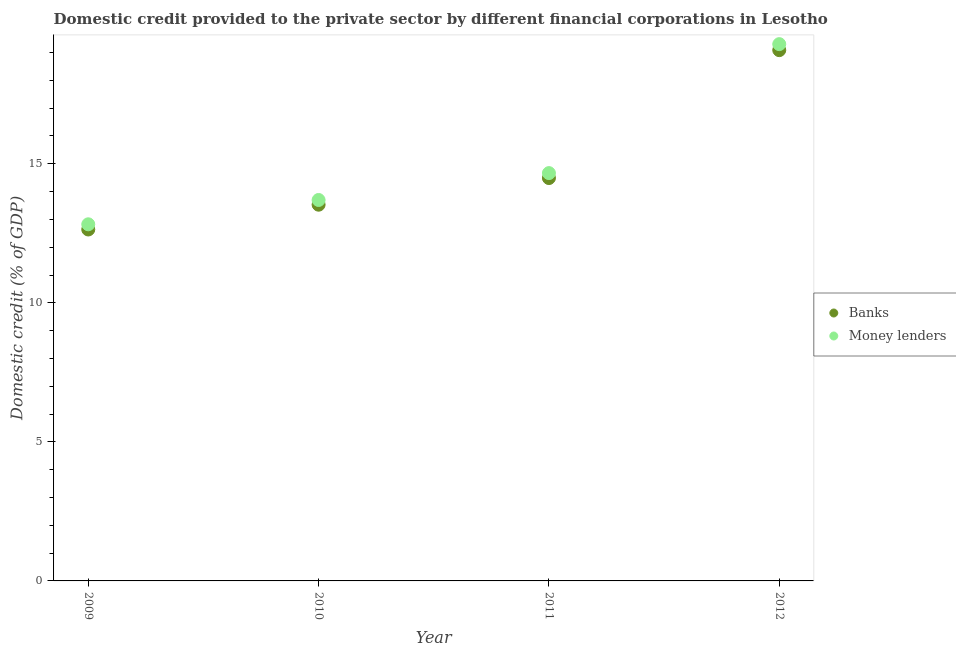How many different coloured dotlines are there?
Offer a terse response. 2. What is the domestic credit provided by banks in 2011?
Provide a short and direct response. 14.49. Across all years, what is the maximum domestic credit provided by money lenders?
Ensure brevity in your answer.  19.3. Across all years, what is the minimum domestic credit provided by money lenders?
Give a very brief answer. 12.82. In which year was the domestic credit provided by banks maximum?
Your response must be concise. 2012. What is the total domestic credit provided by money lenders in the graph?
Ensure brevity in your answer.  60.49. What is the difference between the domestic credit provided by money lenders in 2009 and that in 2011?
Provide a short and direct response. -1.84. What is the difference between the domestic credit provided by money lenders in 2010 and the domestic credit provided by banks in 2009?
Provide a succinct answer. 1.06. What is the average domestic credit provided by money lenders per year?
Provide a short and direct response. 15.12. In the year 2010, what is the difference between the domestic credit provided by money lenders and domestic credit provided by banks?
Provide a short and direct response. 0.17. In how many years, is the domestic credit provided by banks greater than 18 %?
Provide a succinct answer. 1. What is the ratio of the domestic credit provided by money lenders in 2009 to that in 2011?
Offer a very short reply. 0.87. What is the difference between the highest and the second highest domestic credit provided by banks?
Keep it short and to the point. 4.6. What is the difference between the highest and the lowest domestic credit provided by money lenders?
Your answer should be very brief. 6.48. In how many years, is the domestic credit provided by banks greater than the average domestic credit provided by banks taken over all years?
Ensure brevity in your answer.  1. Is the sum of the domestic credit provided by money lenders in 2009 and 2011 greater than the maximum domestic credit provided by banks across all years?
Give a very brief answer. Yes. How many dotlines are there?
Give a very brief answer. 2. How many years are there in the graph?
Ensure brevity in your answer.  4. Are the values on the major ticks of Y-axis written in scientific E-notation?
Your answer should be compact. No. Does the graph contain any zero values?
Ensure brevity in your answer.  No. How many legend labels are there?
Give a very brief answer. 2. How are the legend labels stacked?
Make the answer very short. Vertical. What is the title of the graph?
Give a very brief answer. Domestic credit provided to the private sector by different financial corporations in Lesotho. Does "Long-term debt" appear as one of the legend labels in the graph?
Your response must be concise. No. What is the label or title of the Y-axis?
Provide a short and direct response. Domestic credit (% of GDP). What is the Domestic credit (% of GDP) in Banks in 2009?
Offer a terse response. 12.64. What is the Domestic credit (% of GDP) of Money lenders in 2009?
Your answer should be very brief. 12.82. What is the Domestic credit (% of GDP) in Banks in 2010?
Offer a very short reply. 13.53. What is the Domestic credit (% of GDP) of Money lenders in 2010?
Your response must be concise. 13.7. What is the Domestic credit (% of GDP) in Banks in 2011?
Offer a very short reply. 14.49. What is the Domestic credit (% of GDP) in Money lenders in 2011?
Make the answer very short. 14.67. What is the Domestic credit (% of GDP) in Banks in 2012?
Offer a terse response. 19.09. What is the Domestic credit (% of GDP) in Money lenders in 2012?
Your response must be concise. 19.3. Across all years, what is the maximum Domestic credit (% of GDP) of Banks?
Provide a short and direct response. 19.09. Across all years, what is the maximum Domestic credit (% of GDP) in Money lenders?
Give a very brief answer. 19.3. Across all years, what is the minimum Domestic credit (% of GDP) in Banks?
Give a very brief answer. 12.64. Across all years, what is the minimum Domestic credit (% of GDP) in Money lenders?
Your response must be concise. 12.82. What is the total Domestic credit (% of GDP) of Banks in the graph?
Ensure brevity in your answer.  59.74. What is the total Domestic credit (% of GDP) in Money lenders in the graph?
Your answer should be very brief. 60.49. What is the difference between the Domestic credit (% of GDP) in Banks in 2009 and that in 2010?
Provide a short and direct response. -0.89. What is the difference between the Domestic credit (% of GDP) in Money lenders in 2009 and that in 2010?
Give a very brief answer. -0.87. What is the difference between the Domestic credit (% of GDP) of Banks in 2009 and that in 2011?
Ensure brevity in your answer.  -1.85. What is the difference between the Domestic credit (% of GDP) in Money lenders in 2009 and that in 2011?
Provide a succinct answer. -1.84. What is the difference between the Domestic credit (% of GDP) of Banks in 2009 and that in 2012?
Keep it short and to the point. -6.45. What is the difference between the Domestic credit (% of GDP) of Money lenders in 2009 and that in 2012?
Offer a very short reply. -6.48. What is the difference between the Domestic credit (% of GDP) of Banks in 2010 and that in 2011?
Give a very brief answer. -0.96. What is the difference between the Domestic credit (% of GDP) of Money lenders in 2010 and that in 2011?
Your response must be concise. -0.97. What is the difference between the Domestic credit (% of GDP) of Banks in 2010 and that in 2012?
Your answer should be compact. -5.56. What is the difference between the Domestic credit (% of GDP) of Money lenders in 2010 and that in 2012?
Keep it short and to the point. -5.6. What is the difference between the Domestic credit (% of GDP) of Banks in 2011 and that in 2012?
Offer a very short reply. -4.6. What is the difference between the Domestic credit (% of GDP) in Money lenders in 2011 and that in 2012?
Give a very brief answer. -4.64. What is the difference between the Domestic credit (% of GDP) of Banks in 2009 and the Domestic credit (% of GDP) of Money lenders in 2010?
Your answer should be very brief. -1.06. What is the difference between the Domestic credit (% of GDP) in Banks in 2009 and the Domestic credit (% of GDP) in Money lenders in 2011?
Ensure brevity in your answer.  -2.03. What is the difference between the Domestic credit (% of GDP) of Banks in 2009 and the Domestic credit (% of GDP) of Money lenders in 2012?
Keep it short and to the point. -6.66. What is the difference between the Domestic credit (% of GDP) in Banks in 2010 and the Domestic credit (% of GDP) in Money lenders in 2011?
Provide a short and direct response. -1.14. What is the difference between the Domestic credit (% of GDP) of Banks in 2010 and the Domestic credit (% of GDP) of Money lenders in 2012?
Your answer should be very brief. -5.77. What is the difference between the Domestic credit (% of GDP) in Banks in 2011 and the Domestic credit (% of GDP) in Money lenders in 2012?
Provide a succinct answer. -4.82. What is the average Domestic credit (% of GDP) of Banks per year?
Your answer should be very brief. 14.94. What is the average Domestic credit (% of GDP) in Money lenders per year?
Provide a succinct answer. 15.12. In the year 2009, what is the difference between the Domestic credit (% of GDP) in Banks and Domestic credit (% of GDP) in Money lenders?
Make the answer very short. -0.19. In the year 2010, what is the difference between the Domestic credit (% of GDP) in Banks and Domestic credit (% of GDP) in Money lenders?
Provide a short and direct response. -0.17. In the year 2011, what is the difference between the Domestic credit (% of GDP) in Banks and Domestic credit (% of GDP) in Money lenders?
Give a very brief answer. -0.18. In the year 2012, what is the difference between the Domestic credit (% of GDP) of Banks and Domestic credit (% of GDP) of Money lenders?
Your answer should be compact. -0.22. What is the ratio of the Domestic credit (% of GDP) of Banks in 2009 to that in 2010?
Provide a succinct answer. 0.93. What is the ratio of the Domestic credit (% of GDP) in Money lenders in 2009 to that in 2010?
Provide a succinct answer. 0.94. What is the ratio of the Domestic credit (% of GDP) in Banks in 2009 to that in 2011?
Your response must be concise. 0.87. What is the ratio of the Domestic credit (% of GDP) in Money lenders in 2009 to that in 2011?
Give a very brief answer. 0.87. What is the ratio of the Domestic credit (% of GDP) of Banks in 2009 to that in 2012?
Give a very brief answer. 0.66. What is the ratio of the Domestic credit (% of GDP) in Money lenders in 2009 to that in 2012?
Make the answer very short. 0.66. What is the ratio of the Domestic credit (% of GDP) of Banks in 2010 to that in 2011?
Your response must be concise. 0.93. What is the ratio of the Domestic credit (% of GDP) in Money lenders in 2010 to that in 2011?
Provide a succinct answer. 0.93. What is the ratio of the Domestic credit (% of GDP) of Banks in 2010 to that in 2012?
Your answer should be very brief. 0.71. What is the ratio of the Domestic credit (% of GDP) in Money lenders in 2010 to that in 2012?
Offer a terse response. 0.71. What is the ratio of the Domestic credit (% of GDP) in Banks in 2011 to that in 2012?
Offer a terse response. 0.76. What is the ratio of the Domestic credit (% of GDP) of Money lenders in 2011 to that in 2012?
Offer a very short reply. 0.76. What is the difference between the highest and the second highest Domestic credit (% of GDP) of Banks?
Your answer should be very brief. 4.6. What is the difference between the highest and the second highest Domestic credit (% of GDP) in Money lenders?
Ensure brevity in your answer.  4.64. What is the difference between the highest and the lowest Domestic credit (% of GDP) of Banks?
Make the answer very short. 6.45. What is the difference between the highest and the lowest Domestic credit (% of GDP) in Money lenders?
Provide a succinct answer. 6.48. 